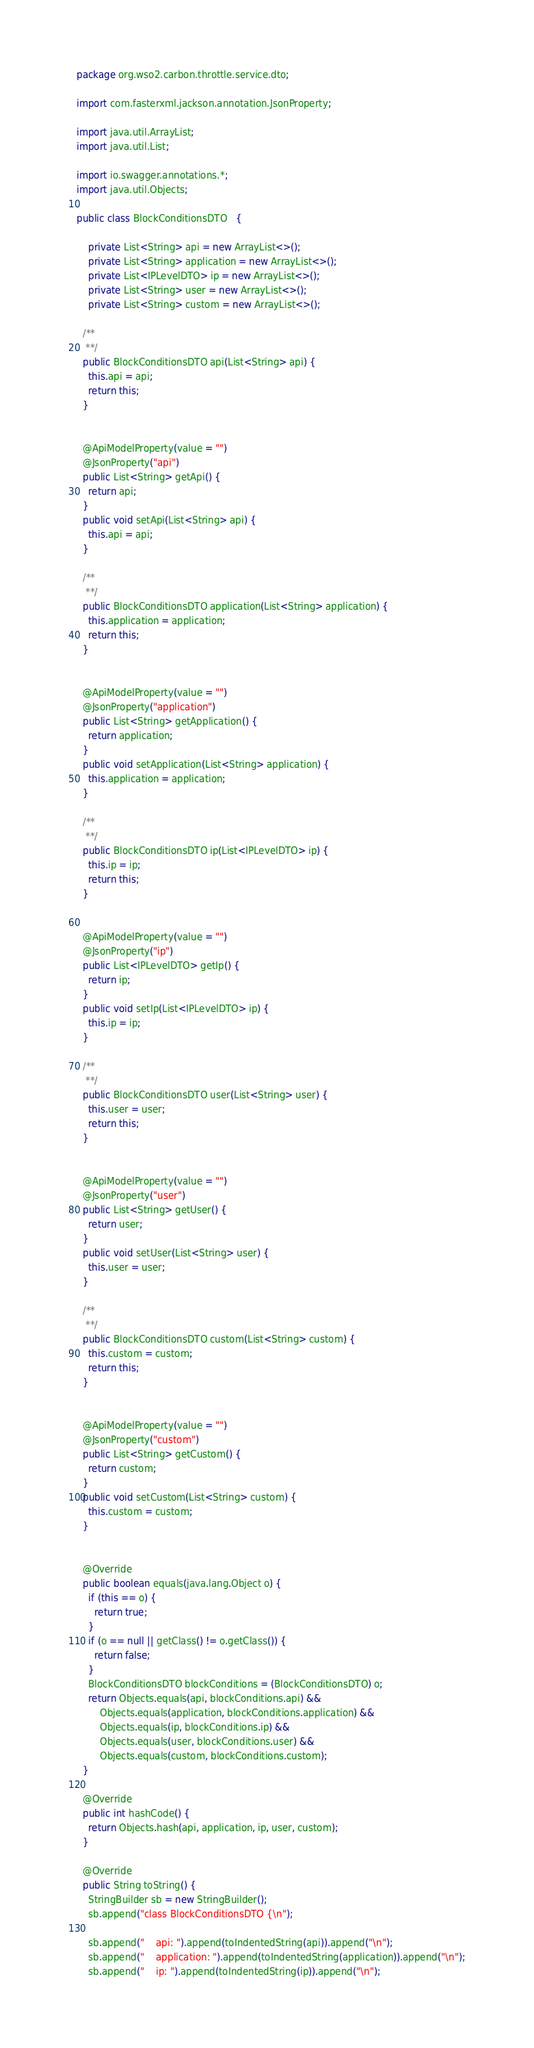<code> <loc_0><loc_0><loc_500><loc_500><_Java_>package org.wso2.carbon.throttle.service.dto;

import com.fasterxml.jackson.annotation.JsonProperty;

import java.util.ArrayList;
import java.util.List;

import io.swagger.annotations.*;
import java.util.Objects;

public class BlockConditionsDTO   {
  
    private List<String> api = new ArrayList<>();
    private List<String> application = new ArrayList<>();
    private List<IPLevelDTO> ip = new ArrayList<>();
    private List<String> user = new ArrayList<>();
    private List<String> custom = new ArrayList<>();

  /**
   **/
  public BlockConditionsDTO api(List<String> api) {
    this.api = api;
    return this;
  }

  
  @ApiModelProperty(value = "")
  @JsonProperty("api")
  public List<String> getApi() {
    return api;
  }
  public void setApi(List<String> api) {
    this.api = api;
  }

  /**
   **/
  public BlockConditionsDTO application(List<String> application) {
    this.application = application;
    return this;
  }

  
  @ApiModelProperty(value = "")
  @JsonProperty("application")
  public List<String> getApplication() {
    return application;
  }
  public void setApplication(List<String> application) {
    this.application = application;
  }

  /**
   **/
  public BlockConditionsDTO ip(List<IPLevelDTO> ip) {
    this.ip = ip;
    return this;
  }

  
  @ApiModelProperty(value = "")
  @JsonProperty("ip")
  public List<IPLevelDTO> getIp() {
    return ip;
  }
  public void setIp(List<IPLevelDTO> ip) {
    this.ip = ip;
  }

  /**
   **/
  public BlockConditionsDTO user(List<String> user) {
    this.user = user;
    return this;
  }

  
  @ApiModelProperty(value = "")
  @JsonProperty("user")
  public List<String> getUser() {
    return user;
  }
  public void setUser(List<String> user) {
    this.user = user;
  }

  /**
   **/
  public BlockConditionsDTO custom(List<String> custom) {
    this.custom = custom;
    return this;
  }

  
  @ApiModelProperty(value = "")
  @JsonProperty("custom")
  public List<String> getCustom() {
    return custom;
  }
  public void setCustom(List<String> custom) {
    this.custom = custom;
  }


  @Override
  public boolean equals(java.lang.Object o) {
    if (this == o) {
      return true;
    }
    if (o == null || getClass() != o.getClass()) {
      return false;
    }
    BlockConditionsDTO blockConditions = (BlockConditionsDTO) o;
    return Objects.equals(api, blockConditions.api) &&
        Objects.equals(application, blockConditions.application) &&
        Objects.equals(ip, blockConditions.ip) &&
        Objects.equals(user, blockConditions.user) &&
        Objects.equals(custom, blockConditions.custom);
  }

  @Override
  public int hashCode() {
    return Objects.hash(api, application, ip, user, custom);
  }

  @Override
  public String toString() {
    StringBuilder sb = new StringBuilder();
    sb.append("class BlockConditionsDTO {\n");
    
    sb.append("    api: ").append(toIndentedString(api)).append("\n");
    sb.append("    application: ").append(toIndentedString(application)).append("\n");
    sb.append("    ip: ").append(toIndentedString(ip)).append("\n");</code> 